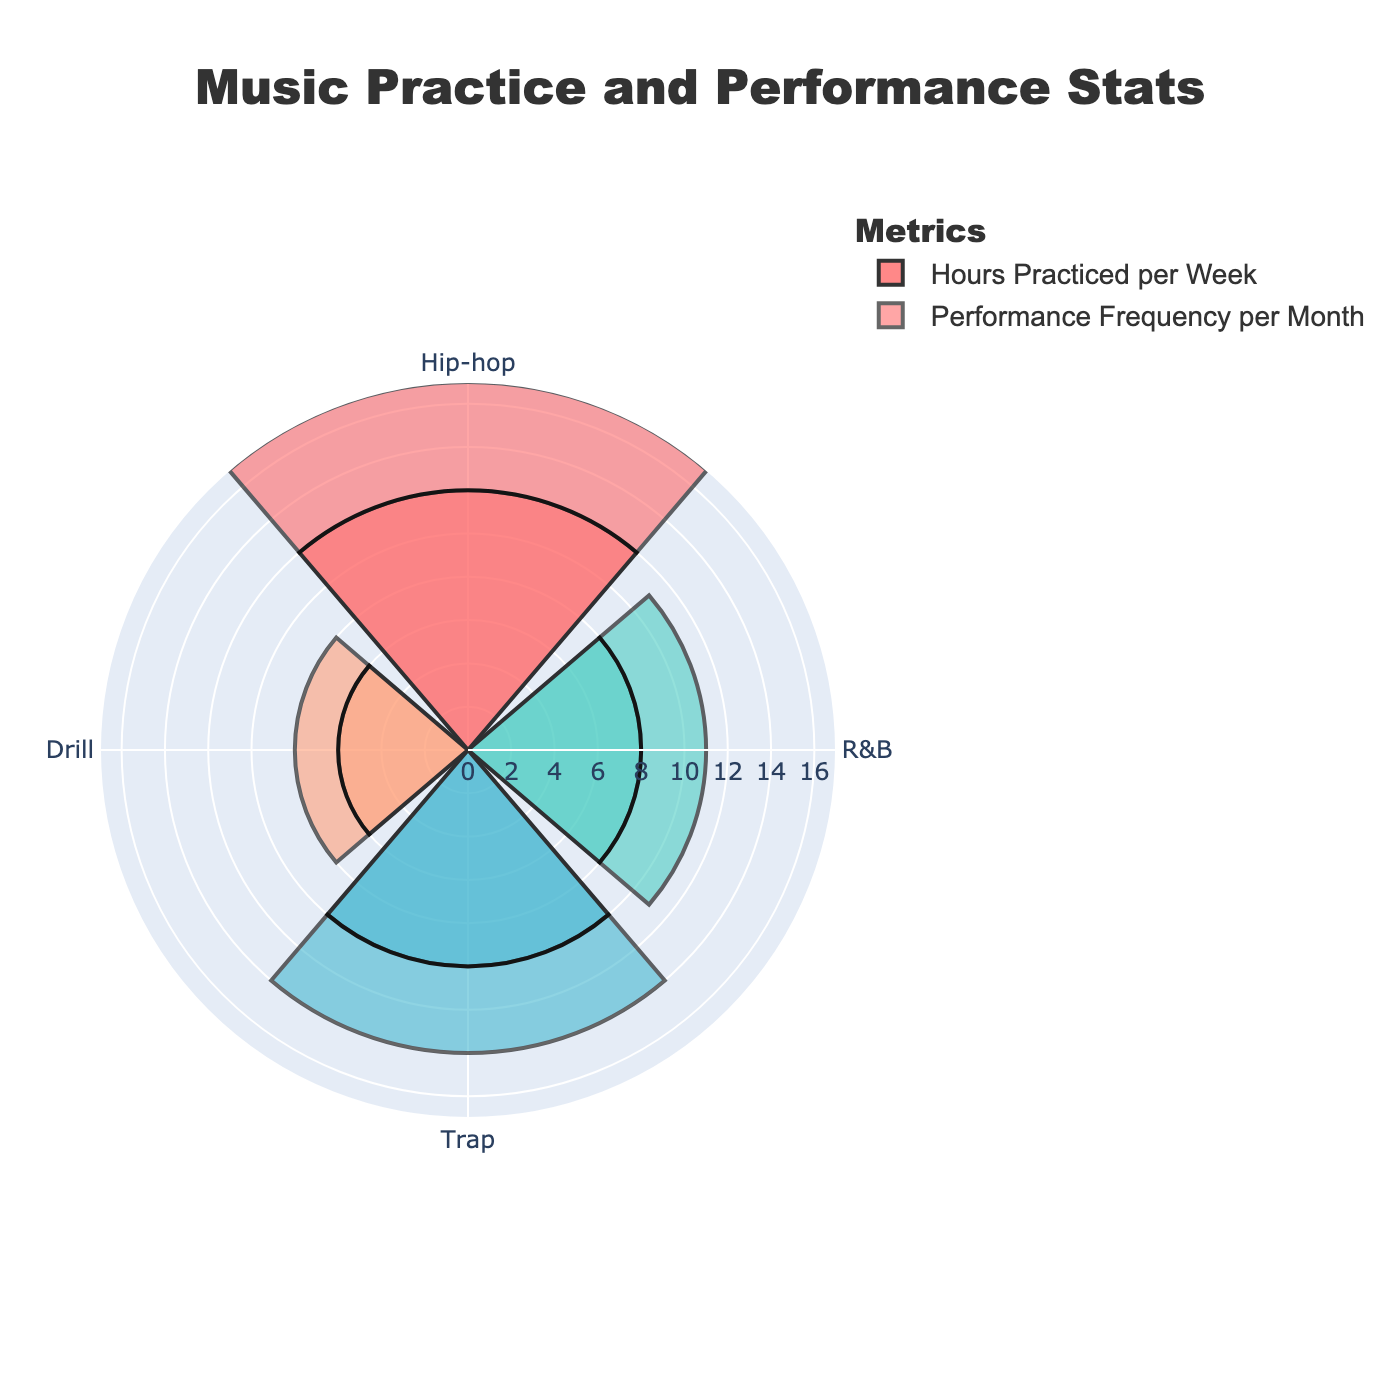What is the title of the chart? The title of the chart is found at the top and usually gives an overview of the chart's content. In this case, it is "Music Practice and Performance Stats".
Answer: Music Practice and Performance Stats Which genre has the highest number of hours practiced per week? Look at the segments labeled with genres and compare their lengths. The longest segment corresponds to Hip-hop, which has 12 hours per week.
Answer: Hip-hop What is the total number of hours you practice per week across all genres? To find the total number of hours practiced per week, sum up the values for all genres: 12 (Hip-hop) + 8 (R&B) + 10 (Trap) + 6 (Drill).
Answer: 36 Which genre has the lowest performance frequency per month? Compare the lengths of the segments of the chart that represent performance frequency per month, the smallest segment corresponds to Drill with 2 performances.
Answer: Drill Is there any genre where the hours practiced per week are the same as the performance frequency per month? Compare the values of hours practiced per week and performance frequency per month for each genre. There are no such matches in the data.
Answer: No How much more do you practice Hip-hop per week compared to Drill? Subtract the hours practiced per week for Drill from those for Hip-hop: 12 (Hip-hop) - 6 (Drill).
Answer: 6 Which genre has the highest overall engagement (hours practiced per week + performance frequency per month)? Sum up the hours practiced per week and performance frequency per month for each genre, and compare the totals. Hip-hop has the highest total: 12 + 5 = 17.
Answer: Hip-hop Which genre has a higher performance frequency per month: R&B or Trap? Compare the values representing the performance frequency per month for R&B and Trap. Trap has a higher frequency of 4 versus R&B's 3.
Answer: Trap How does Trap compare to Hip-hop in terms of the total number of hours practiced per week and performance frequency per month combined? Calculate the combined total for both Hip-hop and Trap: Hip-hop (12 hours + 5 performances = 17) and Trap (10 hours + 4 performances = 14). Hip-hop has a higher combined total than Trap.
Answer: Hip-hop has more combined hours 